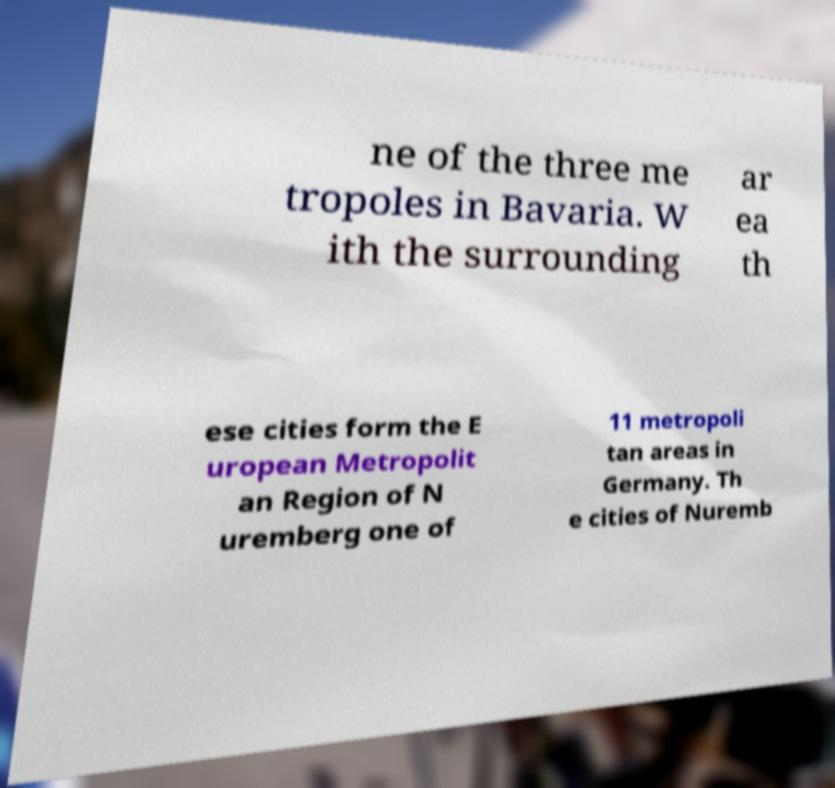For documentation purposes, I need the text within this image transcribed. Could you provide that? ne of the three me tropoles in Bavaria. W ith the surrounding ar ea th ese cities form the E uropean Metropolit an Region of N uremberg one of 11 metropoli tan areas in Germany. Th e cities of Nuremb 